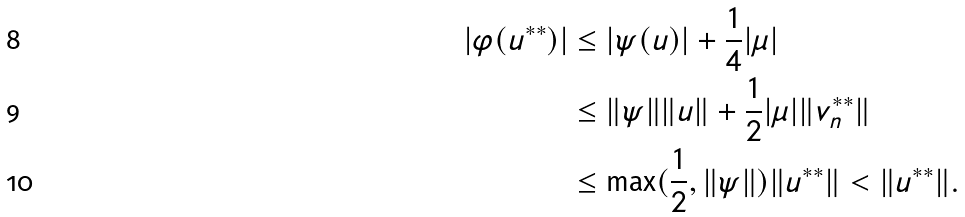Convert formula to latex. <formula><loc_0><loc_0><loc_500><loc_500>| \varphi ( u ^ { * * } ) | & \leq | \psi ( u ) | + \frac { 1 } { 4 } | \mu | \\ & \leq \| \psi \| \| u \| + \frac { 1 } { 2 } | \mu | \| v _ { n } ^ { * * } \| \\ & \leq \max ( \frac { 1 } { 2 } , \| \psi \| ) \| u ^ { * * } \| < \| u ^ { * * } \| .</formula> 